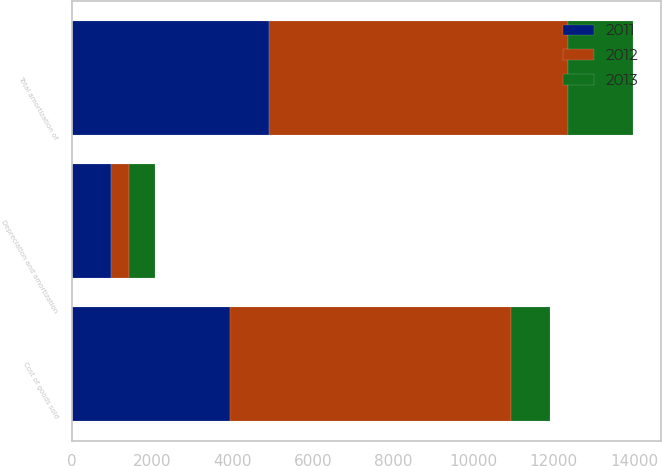Convert chart. <chart><loc_0><loc_0><loc_500><loc_500><stacked_bar_chart><ecel><fcel>Cost of goods sold<fcel>Depreciation and amortization<fcel>Total amortization of<nl><fcel>2012<fcel>7000<fcel>434<fcel>7434<nl><fcel>2013<fcel>983<fcel>656<fcel>1639<nl><fcel>2011<fcel>3927<fcel>983<fcel>4910<nl></chart> 